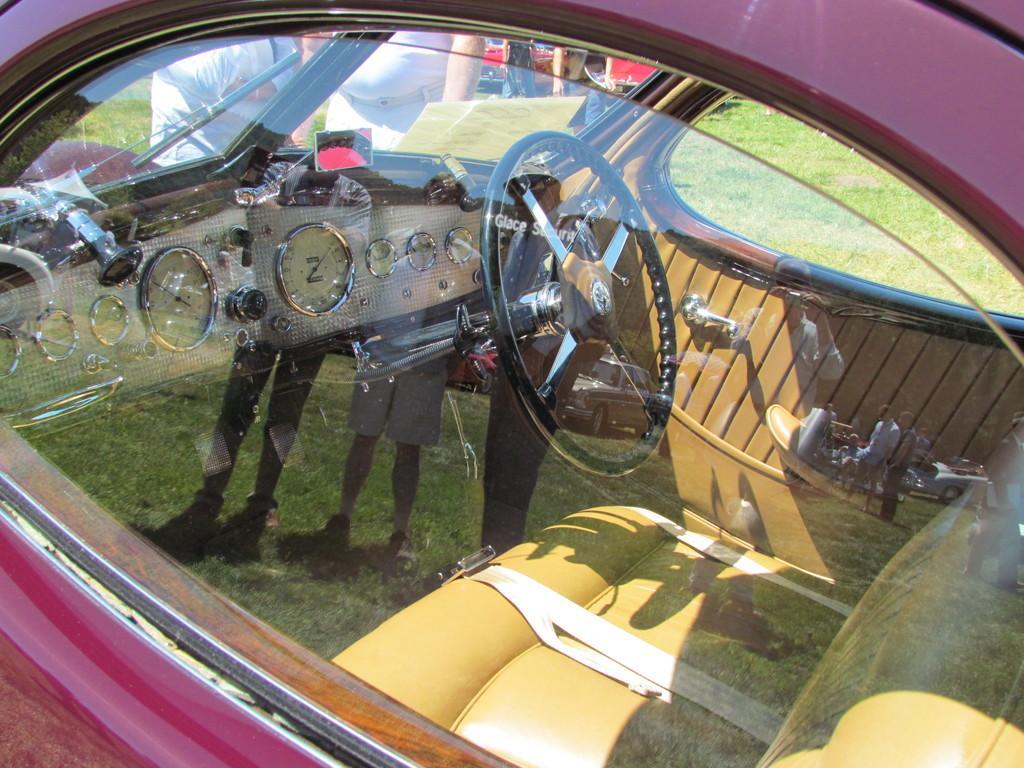Can you describe this image briefly? In this image I can see a car. I can also see steering and a window, I can see a car in maroon color. 